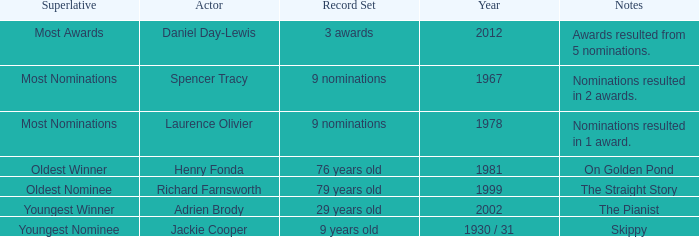In what year had the oldest winner? 1981.0. 